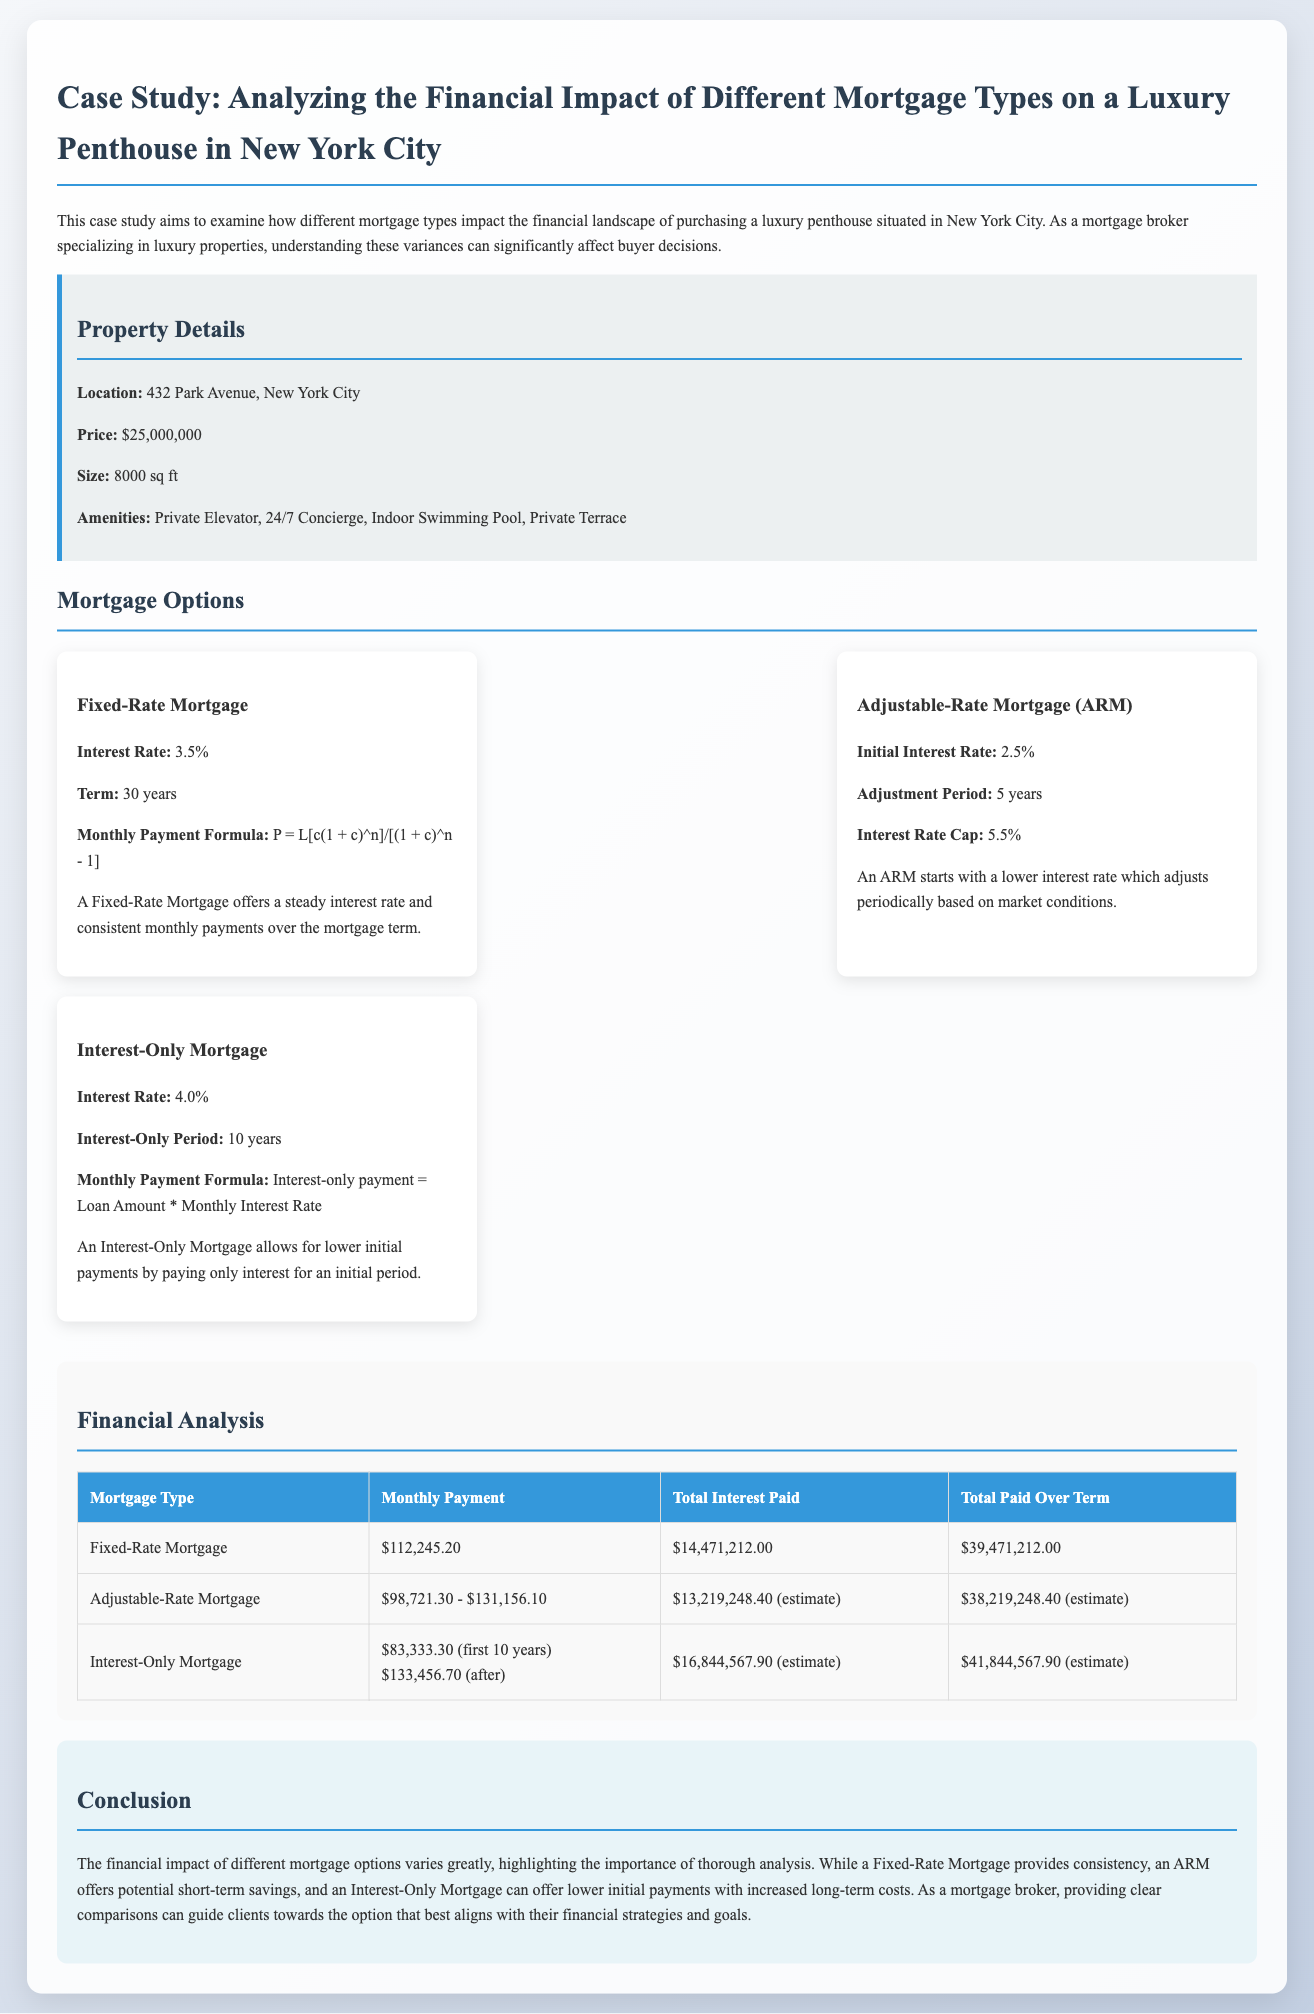What is the location of the property? The location of the property is stated clearly in the document as 432 Park Avenue, New York City.
Answer: 432 Park Avenue, New York City What is the price of the luxury penthouse? The document specifies the price of the luxury penthouse as $25,000,000.
Answer: $25,000,000 What is the interest rate for the Fixed-Rate Mortgage? The interest rate for the Fixed-Rate Mortgage is mentioned as 3.5%.
Answer: 3.5% How much total interest will be paid with a Fixed-Rate Mortgage? The document states that total interest paid with a Fixed-Rate Mortgage will be $14,471,212.00.
Answer: $14,471,212.00 What is the monthly payment for the Interest-Only Mortgage during the first 10 years? The monthly payment for the Interest-Only Mortgage during the first 10 years is provided as $83,333.30.
Answer: $83,333.30 What type of mortgage offers a steady interest rate? The term "Fixed-Rate Mortgage" is used in the document to indicate the type of mortgage that offers a steady interest rate.
Answer: Fixed-Rate Mortgage What is the estimated total paid over the term for the Adjustable-Rate Mortgage? The document estimates the total paid over the term for the Adjustable-Rate Mortgage as $38,219,248.40.
Answer: $38,219,248.40 What is the estimated total interest paid with an Interest-Only Mortgage? The estimated total interest paid with an Interest-Only Mortgage is stated as $16,844,567.90.
Answer: $16,844,567.90 